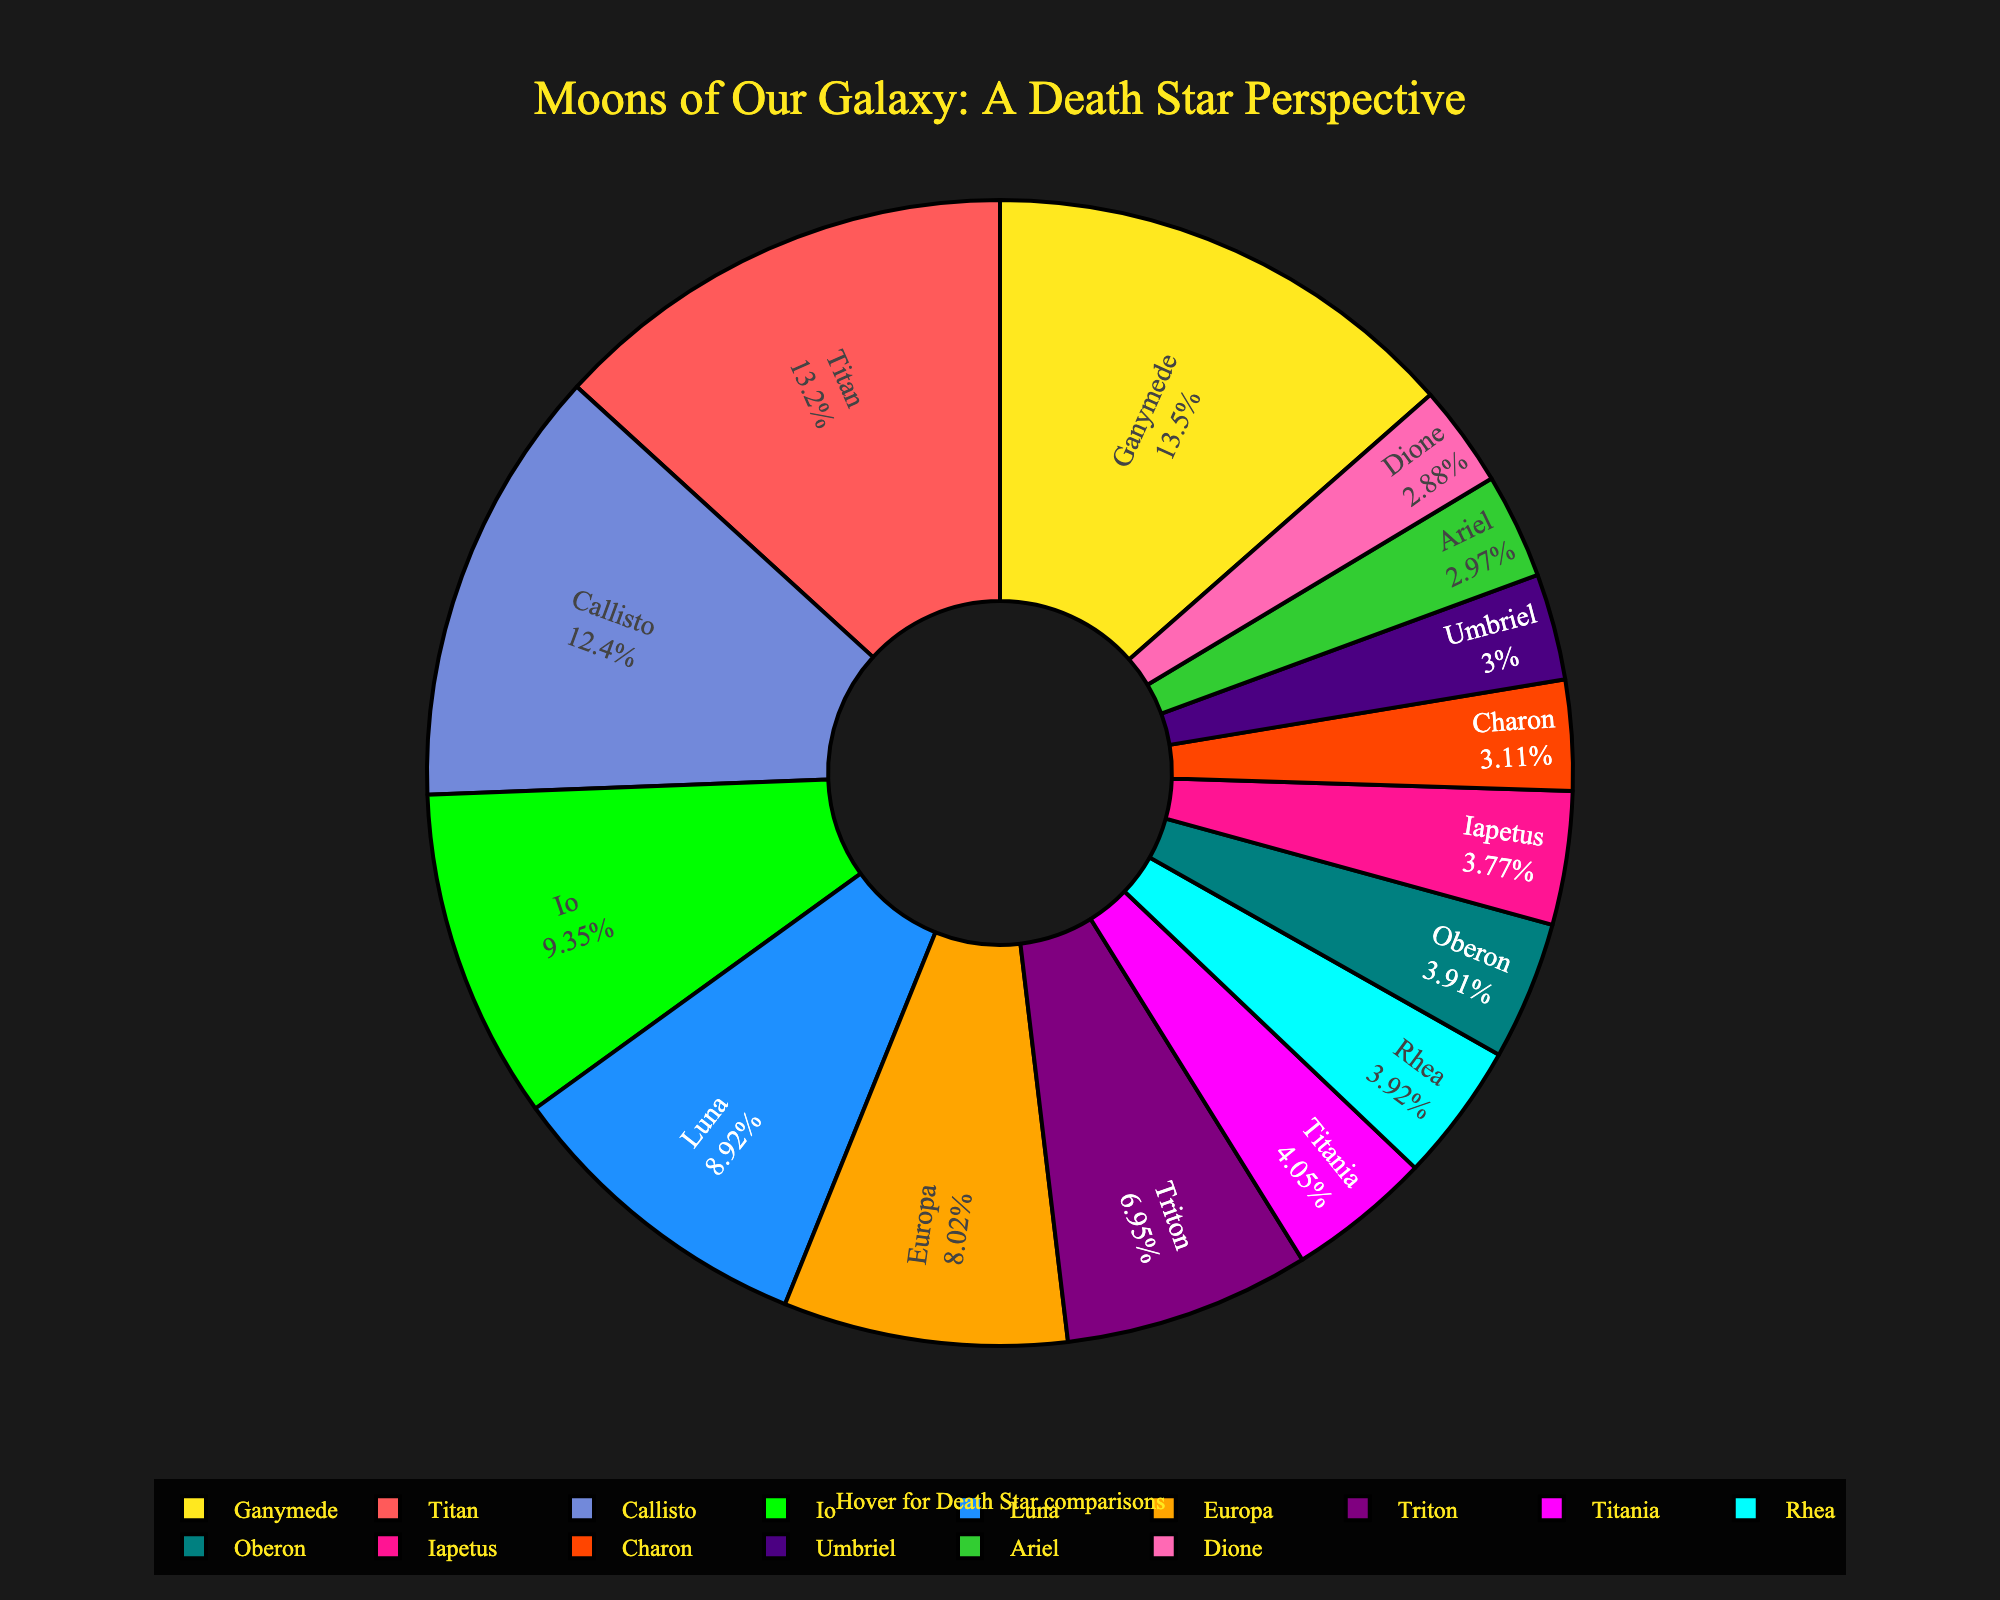which moon is the most similar in size to the Death Star II in the Star Wars universe? According to the chart's hover information, the moon with a size close to "Death Star II" is Titan (5150 km).
Answer: Titan Among the moons listed, which one represents the smallest size comparison in the Star Wars universe? By referring to the chart, the smallest moon in the list is Dione, with a size of 1123 km, compared to the Docking Bay entrance size.
Answer: Dione Which two moons combine to have a size closest to the combined size of Ganymede and Titan? First, sum up the sizes of Ganymede (5268 km) and Titan (5150 km), which equals 10418 km. The two moons closest to this combined size are Ganymede and Titan themselves, as other combinations fall short or exceed this total.
Answer: Ganymede and Titan Which moon’s size is most comparable to the dimension of the original Death Star design? According to the hover information, the moon Europa, with a size of 3122 km, is compared to the Original Death Star design in the chart.
Answer: Europa What is the size difference between Io and Triton? The size of Io is 3642 km, and the size of Triton is 2707 km. Subtracting these two values gives a difference of 3642 km - 2707 km = 935 km.
Answer: 935 km If the sizes of Callisto and Luna are combined, how does their total size compare to that of Ganymede? Adding Callisto’s size (4821 km) to Luna’s size (3475 km) results in 8296 km. Comparing this to Ganymede’s size of 5268 km, 8296 km is significantly greater.
Answer: Larger Which moon represents the hypermatter reactor core size, and how does its size compare to that of Oberon? Rhea represents the hypermatter reactor core size (1527 km), while Oberon’s size is 1523 km. The size difference is 1527 km - 1523 km = 4 km.
Answer: Rhea, 4 km Which moons have sizes close to the Superlaser Primary Ignition component, and which are those moons compared to the Death Star I? Triton, with a size of 1212 km, corresponds to the Superlaser Primary Ignition. Io, with a size of 3642 km, is compared to the Death Star I.
Answer: Triton, Io 